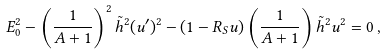<formula> <loc_0><loc_0><loc_500><loc_500>E _ { 0 } ^ { 2 } - \left ( \frac { 1 } { A + 1 } \right ) ^ { 2 } \tilde { h } ^ { 2 } ( u ^ { \prime } ) ^ { 2 } - ( 1 - R _ { S } u ) \left ( \frac { 1 } { A + 1 } \right ) \tilde { h } ^ { 2 } u ^ { 2 } = 0 \, ,</formula> 